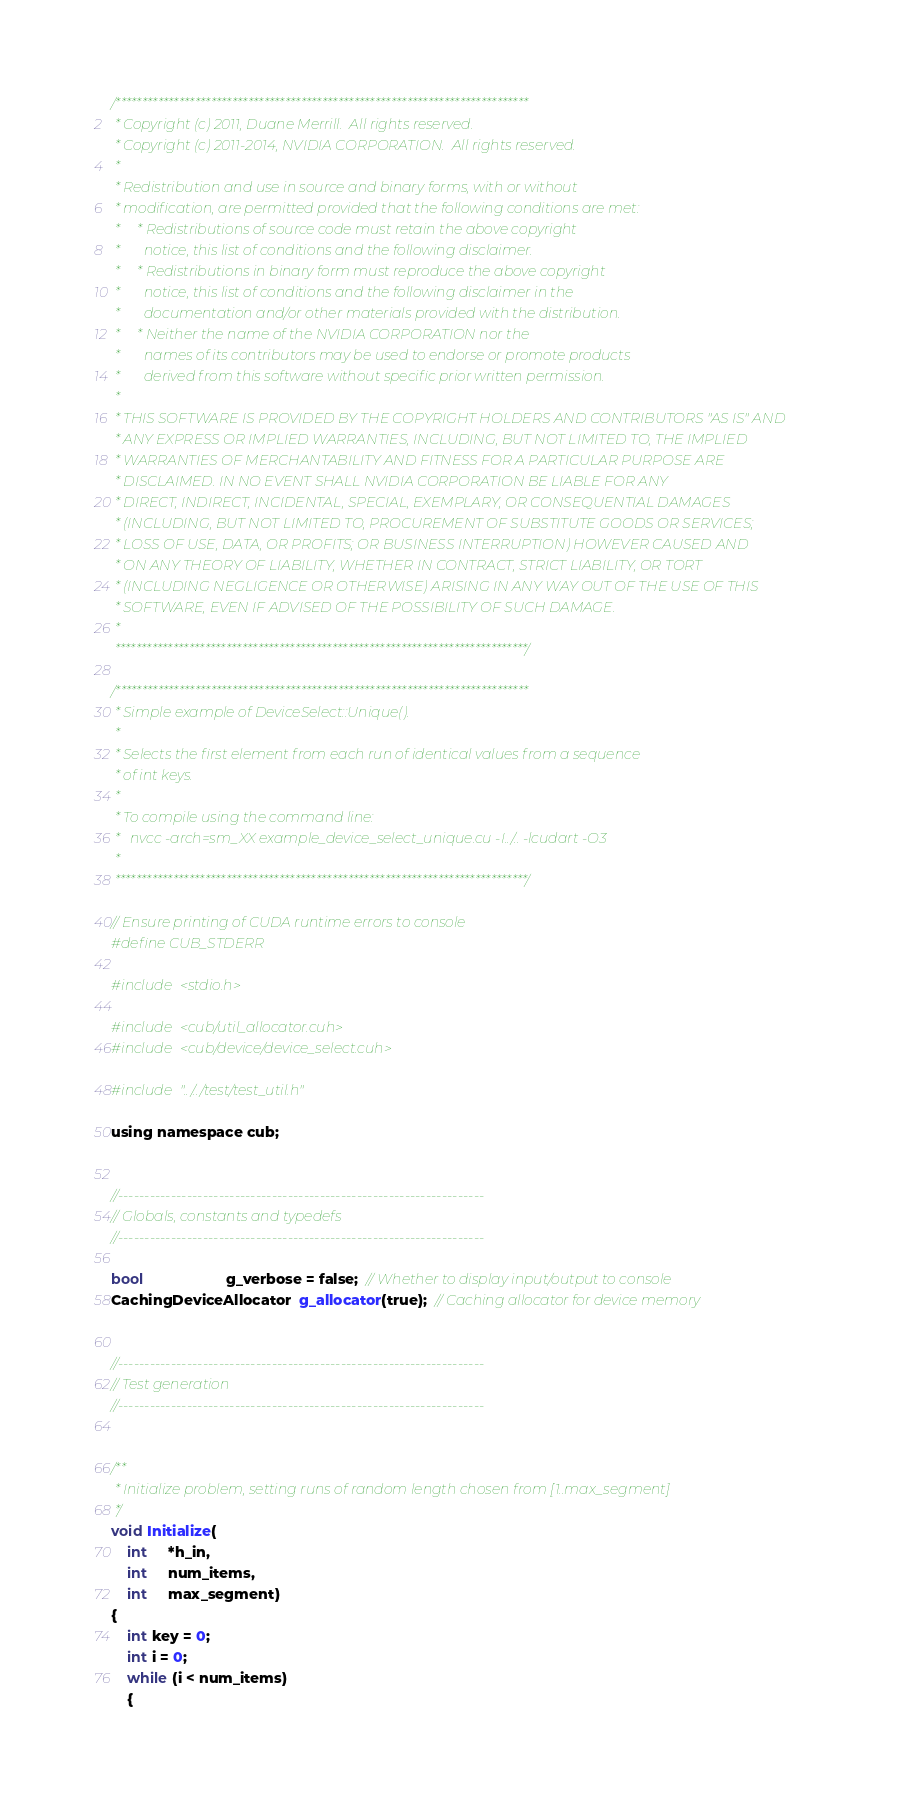Convert code to text. <code><loc_0><loc_0><loc_500><loc_500><_Cuda_>/******************************************************************************
 * Copyright (c) 2011, Duane Merrill.  All rights reserved.
 * Copyright (c) 2011-2014, NVIDIA CORPORATION.  All rights reserved.
 *
 * Redistribution and use in source and binary forms, with or without
 * modification, are permitted provided that the following conditions are met:
 *     * Redistributions of source code must retain the above copyright
 *       notice, this list of conditions and the following disclaimer.
 *     * Redistributions in binary form must reproduce the above copyright
 *       notice, this list of conditions and the following disclaimer in the
 *       documentation and/or other materials provided with the distribution.
 *     * Neither the name of the NVIDIA CORPORATION nor the
 *       names of its contributors may be used to endorse or promote products
 *       derived from this software without specific prior written permission.
 *
 * THIS SOFTWARE IS PROVIDED BY THE COPYRIGHT HOLDERS AND CONTRIBUTORS "AS IS" AND
 * ANY EXPRESS OR IMPLIED WARRANTIES, INCLUDING, BUT NOT LIMITED TO, THE IMPLIED
 * WARRANTIES OF MERCHANTABILITY AND FITNESS FOR A PARTICULAR PURPOSE ARE
 * DISCLAIMED. IN NO EVENT SHALL NVIDIA CORPORATION BE LIABLE FOR ANY
 * DIRECT, INDIRECT, INCIDENTAL, SPECIAL, EXEMPLARY, OR CONSEQUENTIAL DAMAGES
 * (INCLUDING, BUT NOT LIMITED TO, PROCUREMENT OF SUBSTITUTE GOODS OR SERVICES;
 * LOSS OF USE, DATA, OR PROFITS; OR BUSINESS INTERRUPTION) HOWEVER CAUSED AND
 * ON ANY THEORY OF LIABILITY, WHETHER IN CONTRACT, STRICT LIABILITY, OR TORT
 * (INCLUDING NEGLIGENCE OR OTHERWISE) ARISING IN ANY WAY OUT OF THE USE OF THIS
 * SOFTWARE, EVEN IF ADVISED OF THE POSSIBILITY OF SUCH DAMAGE.
 *
 ******************************************************************************/

/******************************************************************************
 * Simple example of DeviceSelect::Unique().
 *
 * Selects the first element from each run of identical values from a sequence
 * of int keys.
 *
 * To compile using the command line:
 *   nvcc -arch=sm_XX example_device_select_unique.cu -I../.. -lcudart -O3
 *
 ******************************************************************************/

// Ensure printing of CUDA runtime errors to console
#define CUB_STDERR

#include <stdio.h>

#include <cub/util_allocator.cuh>
#include <cub/device/device_select.cuh>

#include "../../test/test_util.h"

using namespace cub;


//---------------------------------------------------------------------
// Globals, constants and typedefs
//---------------------------------------------------------------------

bool                    g_verbose = false;  // Whether to display input/output to console
CachingDeviceAllocator  g_allocator(true);  // Caching allocator for device memory


//---------------------------------------------------------------------
// Test generation
//---------------------------------------------------------------------


/**
 * Initialize problem, setting runs of random length chosen from [1..max_segment]
 */
void Initialize(
    int     *h_in,
    int     num_items,
    int     max_segment)
{
    int key = 0;
    int i = 0;
    while (i < num_items)
    {</code> 